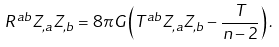<formula> <loc_0><loc_0><loc_500><loc_500>R ^ { a b } Z _ { , a } Z _ { , b } = 8 \pi G \left ( T ^ { a b } Z _ { , a } Z _ { , b } - \frac { T } { n - 2 } \right ) .</formula> 